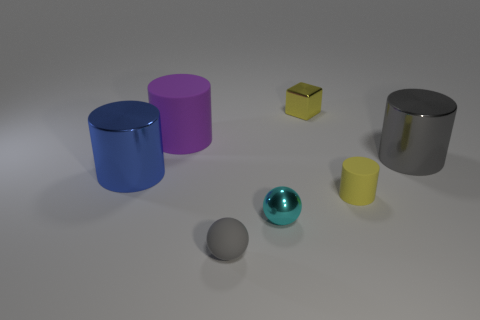Is there any sense of movement or stillness in the arrangement of these objects, and what contributes to that impression? The arrangement of objects conveys a sense of stillness. This is primarily due to the objects' stable positioning on a flat surface and the absence of any dynamic elements like shadows or lines that might suggest motion. The objects are static and arranged in a way that suggests a deliberate but unmoving composition, almost as if they're part of a study in geometry and light. 